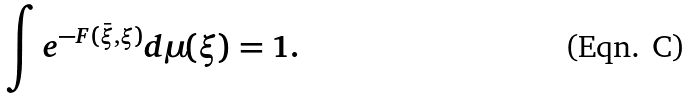<formula> <loc_0><loc_0><loc_500><loc_500>\int e ^ { - F ( \bar { \xi } , \xi ) } d \mu ( \xi ) = 1 .</formula> 